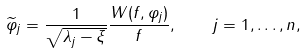<formula> <loc_0><loc_0><loc_500><loc_500>\widetilde { \varphi } _ { j } = \frac { 1 } { \sqrt { \lambda _ { j } - \xi } } \frac { W ( f , \varphi _ { j } ) } { f } , \quad j = 1 , \dots , n ,</formula> 